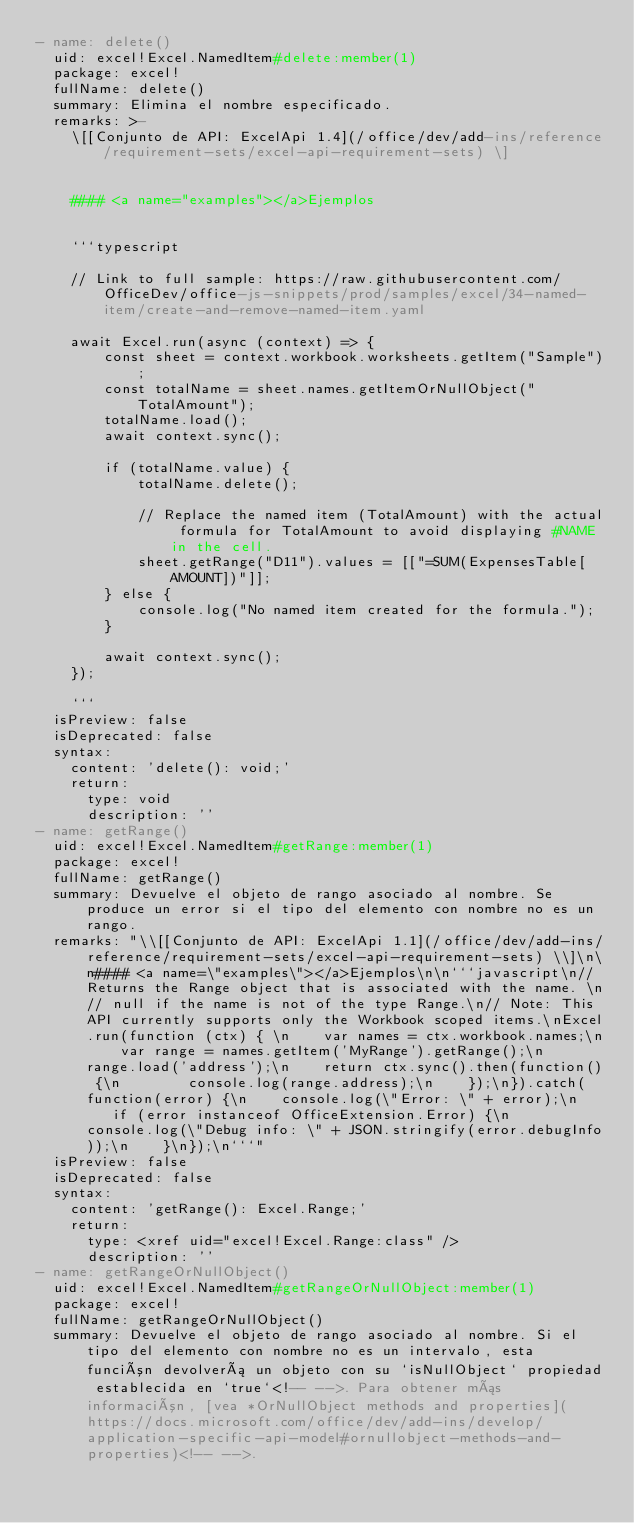Convert code to text. <code><loc_0><loc_0><loc_500><loc_500><_YAML_>- name: delete()
  uid: excel!Excel.NamedItem#delete:member(1)
  package: excel!
  fullName: delete()
  summary: Elimina el nombre especificado.
  remarks: >-
    \[[Conjunto de API: ExcelApi 1.4](/office/dev/add-ins/reference/requirement-sets/excel-api-requirement-sets) \]


    #### <a name="examples"></a>Ejemplos


    ```typescript

    // Link to full sample: https://raw.githubusercontent.com/OfficeDev/office-js-snippets/prod/samples/excel/34-named-item/create-and-remove-named-item.yaml

    await Excel.run(async (context) => {
        const sheet = context.workbook.worksheets.getItem("Sample");
        const totalName = sheet.names.getItemOrNullObject("TotalAmount");
        totalName.load();
        await context.sync();

        if (totalName.value) {
            totalName.delete();

            // Replace the named item (TotalAmount) with the actual formula for TotalAmount to avoid displaying #NAME in the cell.
            sheet.getRange("D11").values = [["=SUM(ExpensesTable[AMOUNT])"]];
        } else {
            console.log("No named item created for the formula.");
        }

        await context.sync();
    });

    ```
  isPreview: false
  isDeprecated: false
  syntax:
    content: 'delete(): void;'
    return:
      type: void
      description: ''
- name: getRange()
  uid: excel!Excel.NamedItem#getRange:member(1)
  package: excel!
  fullName: getRange()
  summary: Devuelve el objeto de rango asociado al nombre. Se produce un error si el tipo del elemento con nombre no es un rango.
  remarks: "\\[[Conjunto de API: ExcelApi 1.1](/office/dev/add-ins/reference/requirement-sets/excel-api-requirement-sets) \\]\n\n#### <a name=\"examples\"></a>Ejemplos\n\n```javascript\n// Returns the Range object that is associated with the name. \n// null if the name is not of the type Range.\n// Note: This API currently supports only the Workbook scoped items.\nExcel.run(function (ctx) { \n    var names = ctx.workbook.names;\n    var range = names.getItem('MyRange').getRange();\n    range.load('address');\n    return ctx.sync().then(function() {\n        console.log(range.address);\n    });\n}).catch(function(error) {\n    console.log(\"Error: \" + error);\n    if (error instanceof OfficeExtension.Error) {\n        console.log(\"Debug info: \" + JSON.stringify(error.debugInfo));\n    }\n});\n```"
  isPreview: false
  isDeprecated: false
  syntax:
    content: 'getRange(): Excel.Range;'
    return:
      type: <xref uid="excel!Excel.Range:class" />
      description: ''
- name: getRangeOrNullObject()
  uid: excel!Excel.NamedItem#getRangeOrNullObject:member(1)
  package: excel!
  fullName: getRangeOrNullObject()
  summary: Devuelve el objeto de rango asociado al nombre. Si el tipo del elemento con nombre no es un intervalo, esta función devolverá un objeto con su `isNullObject` propiedad establecida en `true`<!-- -->. Para obtener más información, [vea *OrNullObject methods and properties](https://docs.microsoft.com/office/dev/add-ins/develop/application-specific-api-model#ornullobject-methods-and-properties)<!-- -->.</code> 